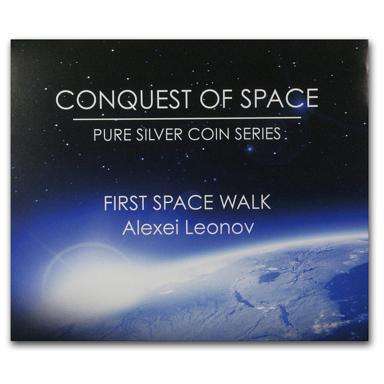Who is Alexei Leonov? Alexei Leonov, a trailblazing Soviet cosmonaut, earned his place in history books as the first person to venture outside the confines of a spacecraft in orbit, carrying out the world's inaugural spacewalk on March 18th, 1965. This momentous endeavor, part of the Voskhod 2 mission, heralded a new era for space exploration and underscored the potential for human adaptability beyond Earth. 